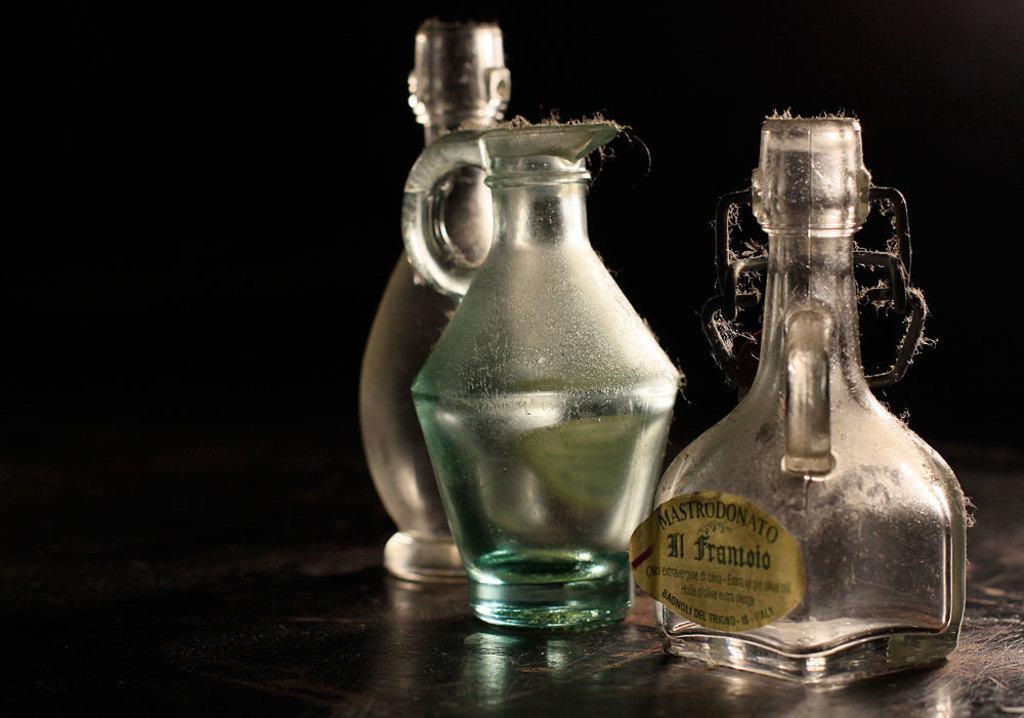Describe this image in one or two sentences. in this image i can see three glass bottles.. the right most bottle has a handle and a note on it, which has written frantolo. in the center there is a blue colored bottle with a handle. behind them there is another glass bottle. 